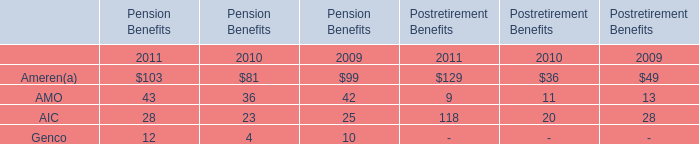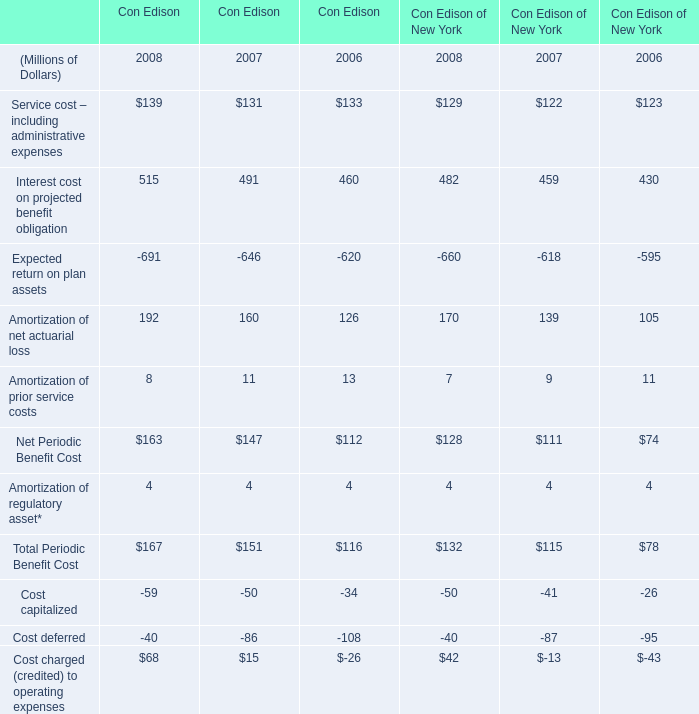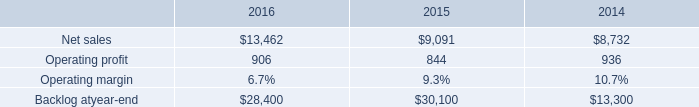What's the current increasing rate of Interest cost on projected benefit obligation in Con Edison? 
Computations: ((515 - 491) / 491)
Answer: 0.04888. 